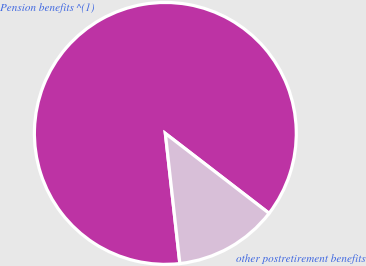<chart> <loc_0><loc_0><loc_500><loc_500><pie_chart><fcel>Pension benefits ^(1)<fcel>other postretirement benefits<nl><fcel>87.21%<fcel>12.79%<nl></chart> 